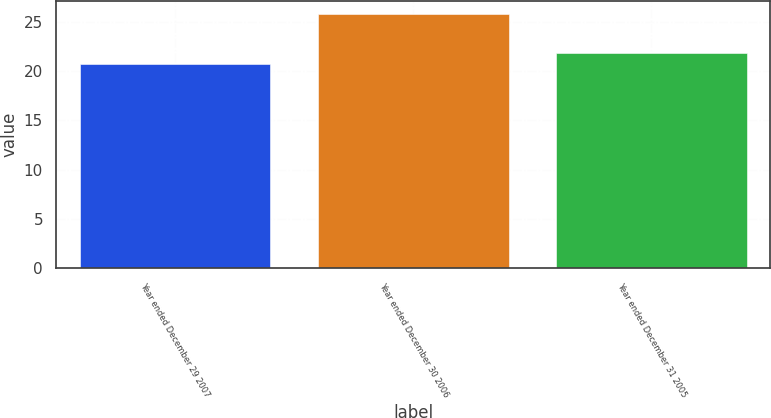<chart> <loc_0><loc_0><loc_500><loc_500><bar_chart><fcel>Year ended December 29 2007<fcel>Year ended December 30 2006<fcel>Year ended December 31 2005<nl><fcel>20.7<fcel>25.8<fcel>21.8<nl></chart> 